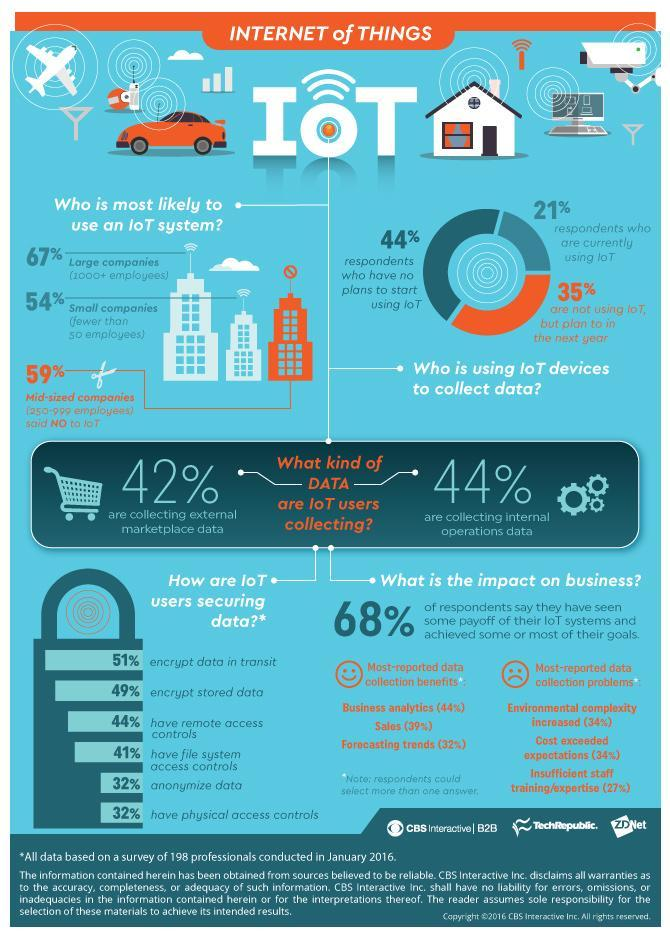What percentage of people are not using IoT?
Answer the question with a short phrase. 79 What is the second point mentioned under how IoT users keep data safe? encrypt stored data What percentage of people who participated in the survey have no interest in IoT? 44% What percentage of people who participated in the survey have an interest in IoT and will incorporate it in the future? 35% What is the color code used to represent the percentage of people not interested in IoT- red, orange, blue, green? orange What percentage of people are using IoT to collect data inside the organisation? 44% 